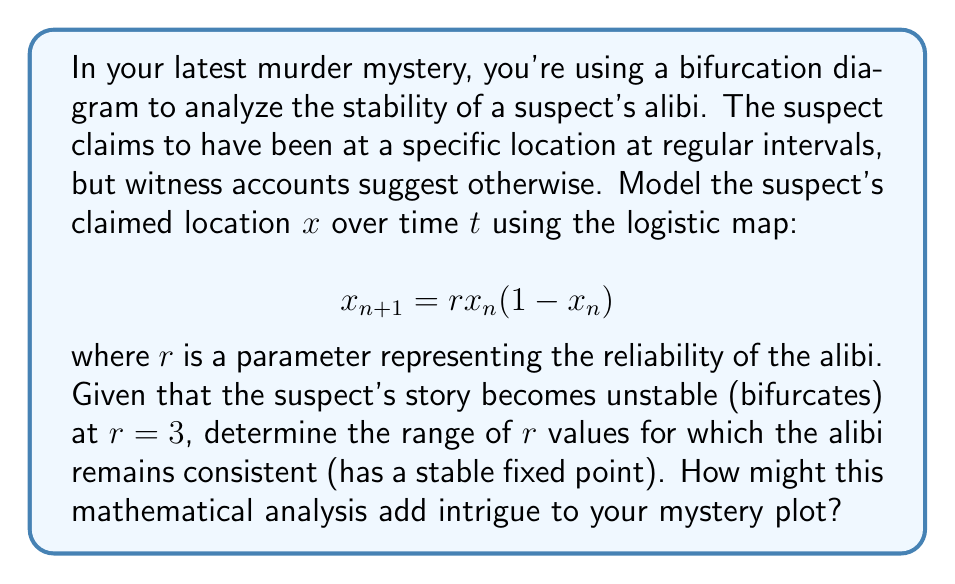Solve this math problem. To analyze the stability of the suspect's alibi using the logistic map, we'll follow these steps:

1) The logistic map is given by $x_{n+1} = rx_n(1-x_n)$, where $x_n$ represents the suspect's claimed location at time $n$, and $r$ is the reliability parameter.

2) To find fixed points, we set $x_{n+1} = x_n = x^*$:
   
   $$x^* = rx^*(1-x^*)$$

3) Solving this equation:
   
   $x^* = 0$ or $x^* = \frac{r-1}{r}$

4) The stability of these fixed points depends on the derivative of the map:
   
   $$\frac{d}{dx}(rx(1-x)) = r(1-2x)$$

5) For stability, we need $|\frac{d}{dx}(rx(1-x))| < 1$ at the fixed point.

6) For $x^* = 0$:
   $|r(1-2(0))| = |r| < 1$, which is true for $-1 < r < 1$

7) For $x^* = \frac{r-1}{r}$:
   $|r(1-2(\frac{r-1}{r}))| = |2-r| < 1$, which is true for $1 < r < 3$

8) Combining these ranges, the alibi remains stable (has a stable fixed point) for $0 < r < 3$.

In the context of your mystery plot, this analysis suggests that the suspect's alibi is consistent when the reliability parameter $r$ is between 0 and 3. As $r$ approaches 3, the alibi becomes increasingly unstable, potentially indicating inconsistencies in the suspect's story. This mathematical framework could add depth to your narrative, allowing you to create tension as investigators scrutinize the suspect's claims and witness accounts.
Answer: $0 < r < 3$ 